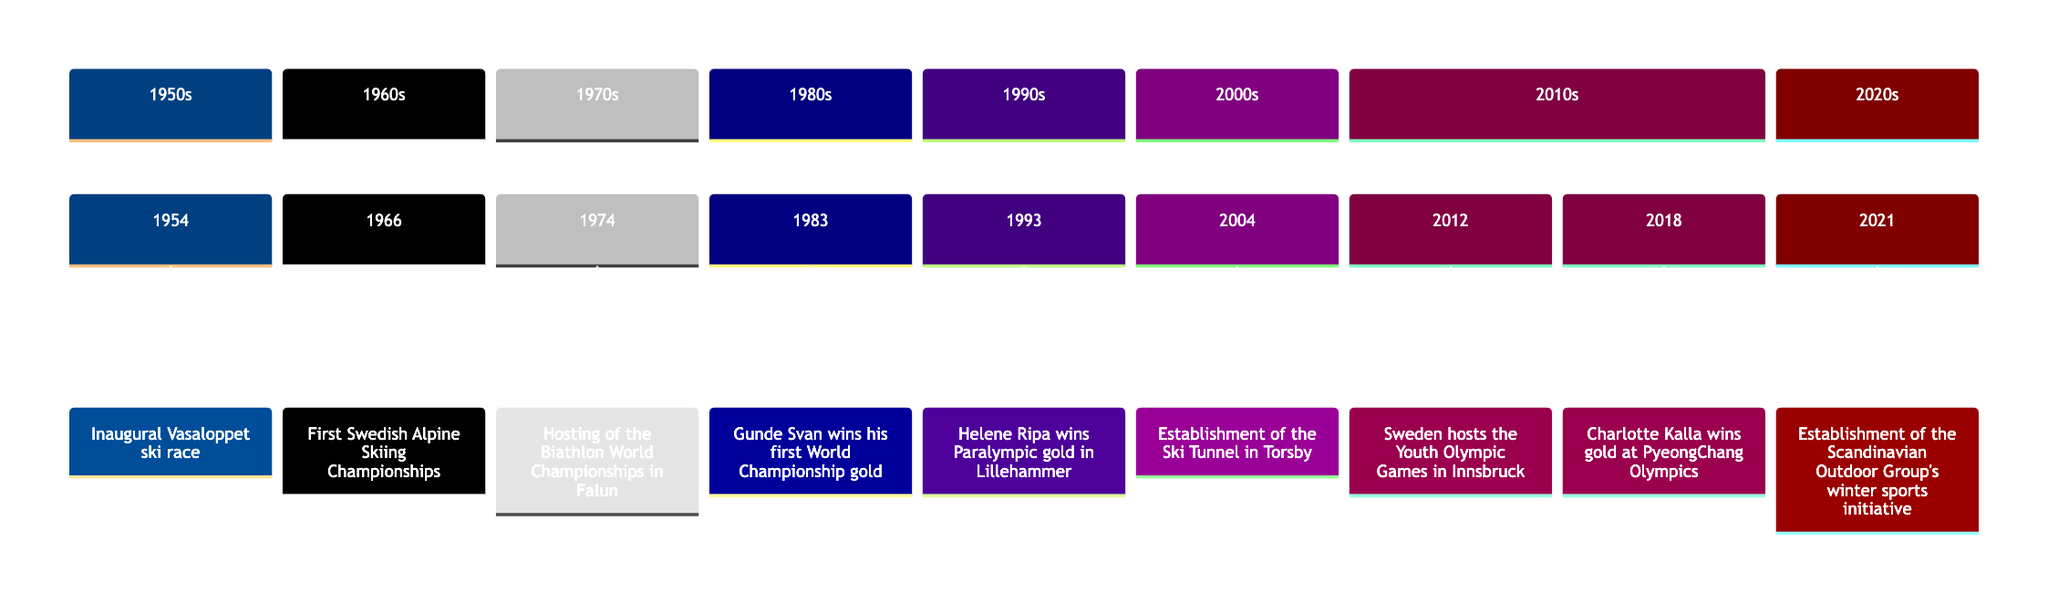What year did the Vasaloppet ski race take place? According to the timeline, the Vasaloppet ski race was inaugurated in 1954. The event is clearly marked at that year.
Answer: 1954 Which event occurred in 2018? In the year 2018, the timeline shows that Charlotte Kalla won gold at the PyeongChang Olympics. This information is explicitly stated for that year.
Answer: Charlotte Kalla wins gold at PyeongChang Olympics How many major winter sports events are listed between 1954 and 2021? To find the number of events, we count the distinct events presented along the timeline from 1954 to 2021. There are a total of 8 events mentioned within this range.
Answer: 8 What significant event happened in 2004? The timeline indicates that in 2004, the establishment of the Ski Tunnel in Torsby occurred. This is a key milestone marked on the timeline for that year.
Answer: Establishment of the Ski Tunnel in Torsby Which athlete won a gold medal at the 1993 Paralympics? The timeline notes that Helene Ripa won gold in cross-country skiing at the Winter Paralympics in 1993. This information directly identifies the athlete associated with that event.
Answer: Helene Ripa What was the first year that Sweden hosted an international winter sports event? The first international winter sports event hosted by Sweden on the timeline is the Biathlon World Championships in 1974. This event is positioned as the first such occasion in the listed timeline.
Answer: 1974 Which event reflects Sweden's initiative towards winter sports sustainability? The timeline states that in 2021, the establishment of the Scandinavian Outdoor Group’s winter sports initiative occurred, highlighting a focus on sustainability in winter sports. This points to the specific event associated with sustainability.
Answer: Establishment of the Scandinavian Outdoor Group's winter sports initiative What is the common sport represented by both Gunde Svan and Charlotte Kalla's achievements? The timeline shows both Gunde Svan's gold medal in cross-country skiing (1983) and Charlotte Kalla's Olympic gold (2018), indicating that the common sport is cross-country skiing. This can be deduced from both events labeled on the timeline.
Answer: Cross-country skiing 